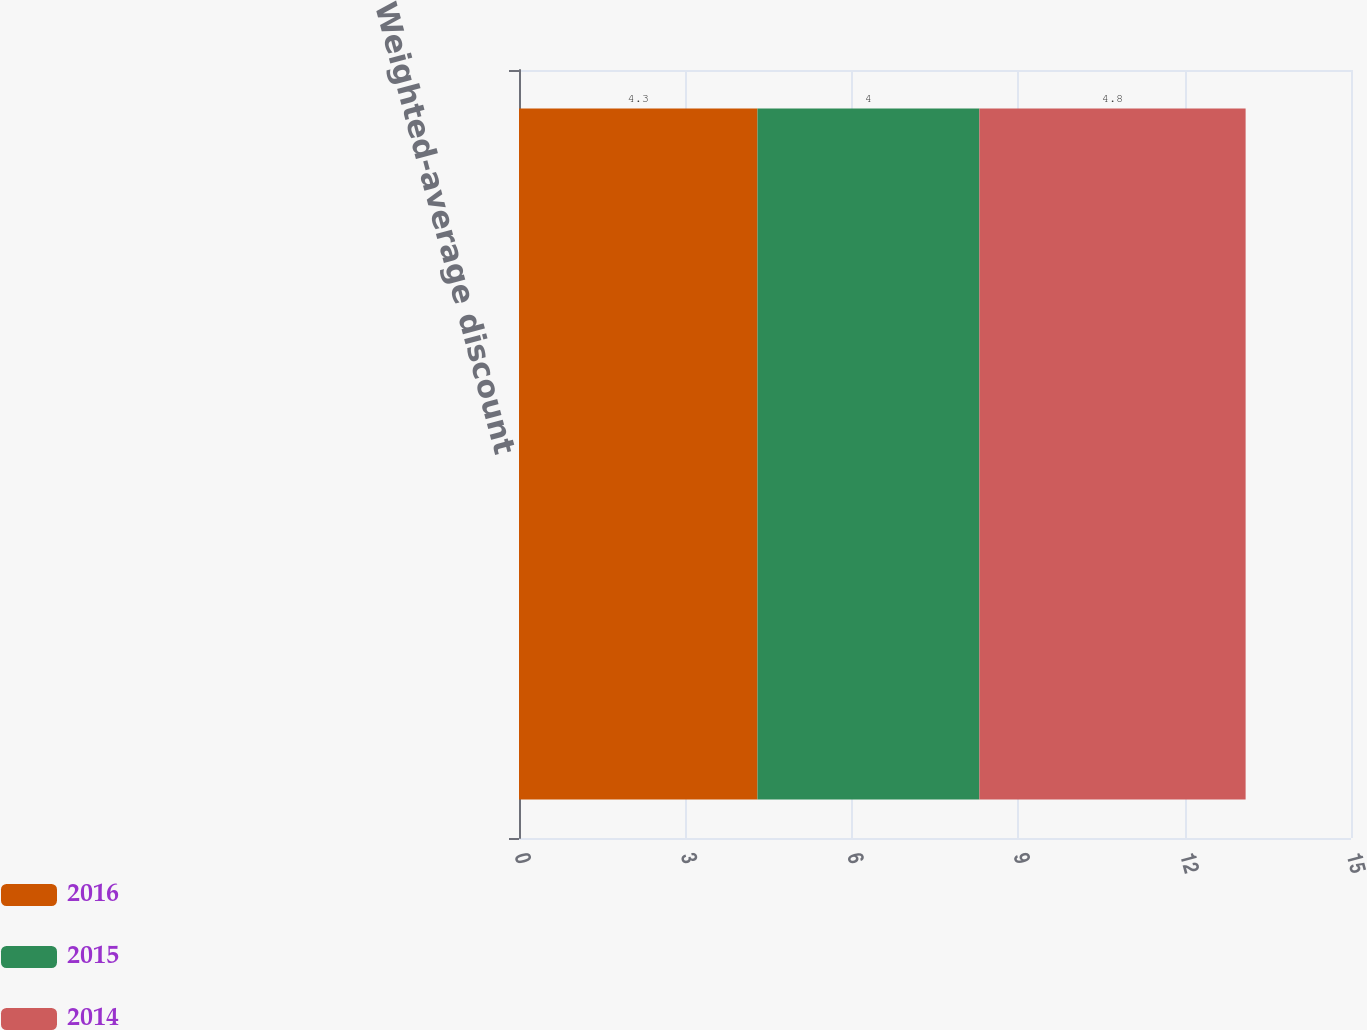Convert chart. <chart><loc_0><loc_0><loc_500><loc_500><stacked_bar_chart><ecel><fcel>Weighted-average discount<nl><fcel>2016<fcel>4.3<nl><fcel>2015<fcel>4<nl><fcel>2014<fcel>4.8<nl></chart> 